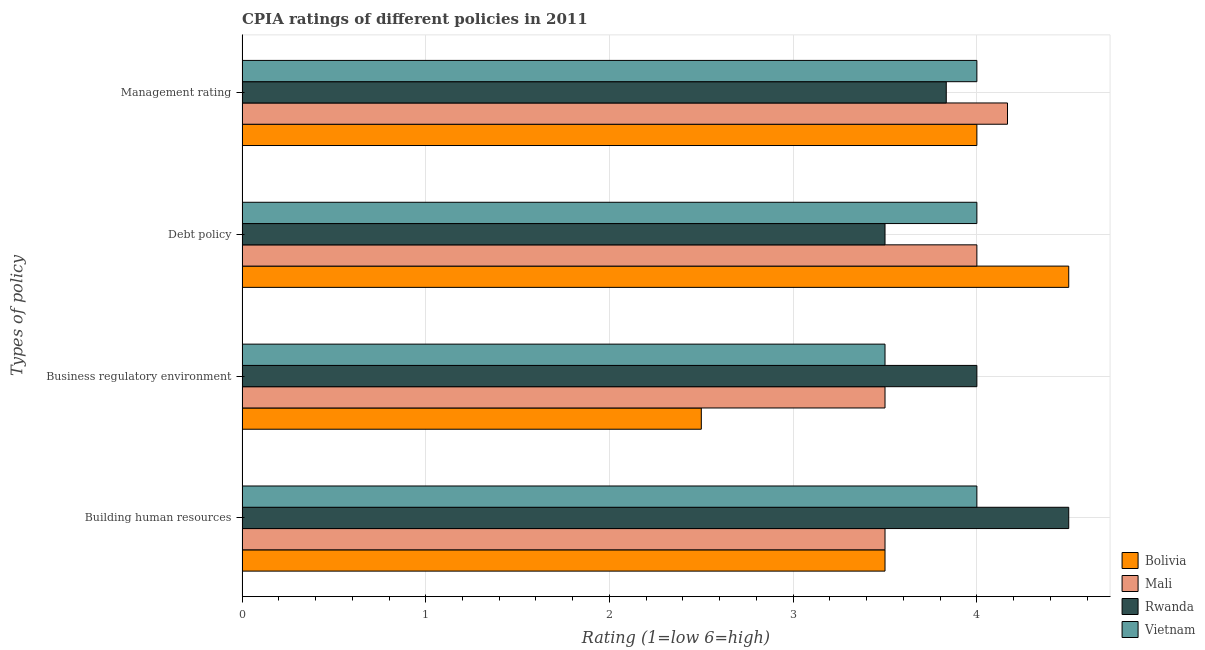How many groups of bars are there?
Your answer should be very brief. 4. Are the number of bars on each tick of the Y-axis equal?
Offer a terse response. Yes. How many bars are there on the 1st tick from the top?
Keep it short and to the point. 4. What is the label of the 1st group of bars from the top?
Offer a very short reply. Management rating. Across all countries, what is the minimum cpia rating of management?
Your answer should be very brief. 3.83. In which country was the cpia rating of building human resources minimum?
Provide a succinct answer. Bolivia. What is the difference between the cpia rating of business regulatory environment in Vietnam and the cpia rating of management in Rwanda?
Offer a terse response. -0.33. What is the average cpia rating of business regulatory environment per country?
Make the answer very short. 3.38. In how many countries, is the cpia rating of debt policy greater than 1.6 ?
Keep it short and to the point. 4. What is the ratio of the cpia rating of business regulatory environment in Vietnam to that in Bolivia?
Give a very brief answer. 1.4. Is the cpia rating of management in Mali less than that in Bolivia?
Your answer should be very brief. No. Is the difference between the cpia rating of building human resources in Rwanda and Vietnam greater than the difference between the cpia rating of business regulatory environment in Rwanda and Vietnam?
Make the answer very short. No. What is the difference between the highest and the second highest cpia rating of management?
Ensure brevity in your answer.  0.17. Is it the case that in every country, the sum of the cpia rating of business regulatory environment and cpia rating of debt policy is greater than the sum of cpia rating of management and cpia rating of building human resources?
Your answer should be compact. No. What does the 2nd bar from the top in Debt policy represents?
Ensure brevity in your answer.  Rwanda. What does the 4th bar from the bottom in Management rating represents?
Your response must be concise. Vietnam. Is it the case that in every country, the sum of the cpia rating of building human resources and cpia rating of business regulatory environment is greater than the cpia rating of debt policy?
Ensure brevity in your answer.  Yes. How many bars are there?
Your answer should be compact. 16. What is the difference between two consecutive major ticks on the X-axis?
Your response must be concise. 1. Are the values on the major ticks of X-axis written in scientific E-notation?
Your answer should be compact. No. Does the graph contain grids?
Offer a terse response. Yes. How many legend labels are there?
Make the answer very short. 4. How are the legend labels stacked?
Offer a very short reply. Vertical. What is the title of the graph?
Give a very brief answer. CPIA ratings of different policies in 2011. Does "Switzerland" appear as one of the legend labels in the graph?
Offer a very short reply. No. What is the label or title of the Y-axis?
Offer a very short reply. Types of policy. What is the Rating (1=low 6=high) in Bolivia in Building human resources?
Provide a succinct answer. 3.5. What is the Rating (1=low 6=high) of Mali in Building human resources?
Your response must be concise. 3.5. What is the Rating (1=low 6=high) in Rwanda in Building human resources?
Provide a short and direct response. 4.5. What is the Rating (1=low 6=high) of Bolivia in Business regulatory environment?
Offer a terse response. 2.5. What is the Rating (1=low 6=high) of Rwanda in Business regulatory environment?
Your answer should be compact. 4. What is the Rating (1=low 6=high) in Vietnam in Business regulatory environment?
Provide a succinct answer. 3.5. What is the Rating (1=low 6=high) of Bolivia in Debt policy?
Provide a short and direct response. 4.5. What is the Rating (1=low 6=high) in Mali in Debt policy?
Provide a short and direct response. 4. What is the Rating (1=low 6=high) in Bolivia in Management rating?
Ensure brevity in your answer.  4. What is the Rating (1=low 6=high) of Mali in Management rating?
Offer a very short reply. 4.17. What is the Rating (1=low 6=high) of Rwanda in Management rating?
Provide a short and direct response. 3.83. Across all Types of policy, what is the maximum Rating (1=low 6=high) of Bolivia?
Your answer should be very brief. 4.5. Across all Types of policy, what is the maximum Rating (1=low 6=high) of Mali?
Your answer should be compact. 4.17. Across all Types of policy, what is the maximum Rating (1=low 6=high) of Rwanda?
Offer a very short reply. 4.5. Across all Types of policy, what is the minimum Rating (1=low 6=high) of Bolivia?
Make the answer very short. 2.5. What is the total Rating (1=low 6=high) in Bolivia in the graph?
Give a very brief answer. 14.5. What is the total Rating (1=low 6=high) of Mali in the graph?
Your response must be concise. 15.17. What is the total Rating (1=low 6=high) in Rwanda in the graph?
Offer a very short reply. 15.83. What is the total Rating (1=low 6=high) in Vietnam in the graph?
Provide a succinct answer. 15.5. What is the difference between the Rating (1=low 6=high) in Bolivia in Building human resources and that in Business regulatory environment?
Make the answer very short. 1. What is the difference between the Rating (1=low 6=high) of Mali in Building human resources and that in Business regulatory environment?
Your answer should be compact. 0. What is the difference between the Rating (1=low 6=high) in Bolivia in Building human resources and that in Debt policy?
Offer a terse response. -1. What is the difference between the Rating (1=low 6=high) in Mali in Building human resources and that in Debt policy?
Ensure brevity in your answer.  -0.5. What is the difference between the Rating (1=low 6=high) of Rwanda in Building human resources and that in Debt policy?
Offer a very short reply. 1. What is the difference between the Rating (1=low 6=high) of Vietnam in Building human resources and that in Debt policy?
Offer a very short reply. 0. What is the difference between the Rating (1=low 6=high) of Bolivia in Building human resources and that in Management rating?
Provide a succinct answer. -0.5. What is the difference between the Rating (1=low 6=high) of Rwanda in Building human resources and that in Management rating?
Make the answer very short. 0.67. What is the difference between the Rating (1=low 6=high) in Rwanda in Business regulatory environment and that in Debt policy?
Keep it short and to the point. 0.5. What is the difference between the Rating (1=low 6=high) in Vietnam in Business regulatory environment and that in Debt policy?
Give a very brief answer. -0.5. What is the difference between the Rating (1=low 6=high) of Mali in Business regulatory environment and that in Management rating?
Your answer should be compact. -0.67. What is the difference between the Rating (1=low 6=high) in Vietnam in Business regulatory environment and that in Management rating?
Keep it short and to the point. -0.5. What is the difference between the Rating (1=low 6=high) in Bolivia in Debt policy and that in Management rating?
Ensure brevity in your answer.  0.5. What is the difference between the Rating (1=low 6=high) of Rwanda in Debt policy and that in Management rating?
Make the answer very short. -0.33. What is the difference between the Rating (1=low 6=high) of Vietnam in Debt policy and that in Management rating?
Your response must be concise. 0. What is the difference between the Rating (1=low 6=high) of Bolivia in Building human resources and the Rating (1=low 6=high) of Mali in Business regulatory environment?
Give a very brief answer. 0. What is the difference between the Rating (1=low 6=high) in Bolivia in Building human resources and the Rating (1=low 6=high) in Rwanda in Business regulatory environment?
Offer a very short reply. -0.5. What is the difference between the Rating (1=low 6=high) of Mali in Building human resources and the Rating (1=low 6=high) of Rwanda in Business regulatory environment?
Give a very brief answer. -0.5. What is the difference between the Rating (1=low 6=high) in Rwanda in Building human resources and the Rating (1=low 6=high) in Vietnam in Business regulatory environment?
Offer a very short reply. 1. What is the difference between the Rating (1=low 6=high) of Bolivia in Building human resources and the Rating (1=low 6=high) of Mali in Debt policy?
Keep it short and to the point. -0.5. What is the difference between the Rating (1=low 6=high) in Bolivia in Building human resources and the Rating (1=low 6=high) in Rwanda in Debt policy?
Provide a short and direct response. 0. What is the difference between the Rating (1=low 6=high) of Bolivia in Building human resources and the Rating (1=low 6=high) of Vietnam in Debt policy?
Make the answer very short. -0.5. What is the difference between the Rating (1=low 6=high) of Bolivia in Building human resources and the Rating (1=low 6=high) of Vietnam in Management rating?
Make the answer very short. -0.5. What is the difference between the Rating (1=low 6=high) in Mali in Building human resources and the Rating (1=low 6=high) in Rwanda in Management rating?
Offer a very short reply. -0.33. What is the difference between the Rating (1=low 6=high) in Rwanda in Building human resources and the Rating (1=low 6=high) in Vietnam in Management rating?
Give a very brief answer. 0.5. What is the difference between the Rating (1=low 6=high) in Bolivia in Business regulatory environment and the Rating (1=low 6=high) in Rwanda in Debt policy?
Keep it short and to the point. -1. What is the difference between the Rating (1=low 6=high) of Mali in Business regulatory environment and the Rating (1=low 6=high) of Vietnam in Debt policy?
Provide a short and direct response. -0.5. What is the difference between the Rating (1=low 6=high) in Bolivia in Business regulatory environment and the Rating (1=low 6=high) in Mali in Management rating?
Provide a short and direct response. -1.67. What is the difference between the Rating (1=low 6=high) of Bolivia in Business regulatory environment and the Rating (1=low 6=high) of Rwanda in Management rating?
Give a very brief answer. -1.33. What is the difference between the Rating (1=low 6=high) in Bolivia in Business regulatory environment and the Rating (1=low 6=high) in Vietnam in Management rating?
Ensure brevity in your answer.  -1.5. What is the difference between the Rating (1=low 6=high) of Mali in Business regulatory environment and the Rating (1=low 6=high) of Rwanda in Management rating?
Offer a very short reply. -0.33. What is the difference between the Rating (1=low 6=high) of Mali in Business regulatory environment and the Rating (1=low 6=high) of Vietnam in Management rating?
Offer a terse response. -0.5. What is the difference between the Rating (1=low 6=high) in Rwanda in Business regulatory environment and the Rating (1=low 6=high) in Vietnam in Management rating?
Ensure brevity in your answer.  0. What is the difference between the Rating (1=low 6=high) in Bolivia in Debt policy and the Rating (1=low 6=high) in Mali in Management rating?
Your answer should be compact. 0.33. What is the difference between the Rating (1=low 6=high) of Bolivia in Debt policy and the Rating (1=low 6=high) of Rwanda in Management rating?
Offer a very short reply. 0.67. What is the average Rating (1=low 6=high) in Bolivia per Types of policy?
Make the answer very short. 3.62. What is the average Rating (1=low 6=high) in Mali per Types of policy?
Offer a very short reply. 3.79. What is the average Rating (1=low 6=high) of Rwanda per Types of policy?
Your answer should be very brief. 3.96. What is the average Rating (1=low 6=high) in Vietnam per Types of policy?
Your answer should be compact. 3.88. What is the difference between the Rating (1=low 6=high) of Bolivia and Rating (1=low 6=high) of Mali in Building human resources?
Your answer should be very brief. 0. What is the difference between the Rating (1=low 6=high) of Bolivia and Rating (1=low 6=high) of Rwanda in Building human resources?
Make the answer very short. -1. What is the difference between the Rating (1=low 6=high) in Bolivia and Rating (1=low 6=high) in Vietnam in Building human resources?
Your answer should be very brief. -0.5. What is the difference between the Rating (1=low 6=high) in Bolivia and Rating (1=low 6=high) in Rwanda in Business regulatory environment?
Your answer should be compact. -1.5. What is the difference between the Rating (1=low 6=high) in Mali and Rating (1=low 6=high) in Rwanda in Business regulatory environment?
Offer a terse response. -0.5. What is the difference between the Rating (1=low 6=high) in Mali and Rating (1=low 6=high) in Vietnam in Business regulatory environment?
Offer a very short reply. 0. What is the difference between the Rating (1=low 6=high) of Rwanda and Rating (1=low 6=high) of Vietnam in Business regulatory environment?
Offer a terse response. 0.5. What is the difference between the Rating (1=low 6=high) of Bolivia and Rating (1=low 6=high) of Rwanda in Debt policy?
Keep it short and to the point. 1. What is the difference between the Rating (1=low 6=high) of Mali and Rating (1=low 6=high) of Vietnam in Debt policy?
Keep it short and to the point. 0. What is the difference between the Rating (1=low 6=high) of Bolivia and Rating (1=low 6=high) of Mali in Management rating?
Keep it short and to the point. -0.17. What is the difference between the Rating (1=low 6=high) in Bolivia and Rating (1=low 6=high) in Vietnam in Management rating?
Offer a terse response. 0. What is the difference between the Rating (1=low 6=high) in Mali and Rating (1=low 6=high) in Rwanda in Management rating?
Your response must be concise. 0.33. What is the difference between the Rating (1=low 6=high) in Mali and Rating (1=low 6=high) in Vietnam in Management rating?
Your answer should be compact. 0.17. What is the difference between the Rating (1=low 6=high) of Rwanda and Rating (1=low 6=high) of Vietnam in Management rating?
Keep it short and to the point. -0.17. What is the ratio of the Rating (1=low 6=high) in Bolivia in Building human resources to that in Business regulatory environment?
Provide a short and direct response. 1.4. What is the ratio of the Rating (1=low 6=high) in Mali in Building human resources to that in Business regulatory environment?
Ensure brevity in your answer.  1. What is the ratio of the Rating (1=low 6=high) of Vietnam in Building human resources to that in Business regulatory environment?
Your response must be concise. 1.14. What is the ratio of the Rating (1=low 6=high) of Bolivia in Building human resources to that in Debt policy?
Keep it short and to the point. 0.78. What is the ratio of the Rating (1=low 6=high) of Vietnam in Building human resources to that in Debt policy?
Make the answer very short. 1. What is the ratio of the Rating (1=low 6=high) in Bolivia in Building human resources to that in Management rating?
Make the answer very short. 0.88. What is the ratio of the Rating (1=low 6=high) in Mali in Building human resources to that in Management rating?
Keep it short and to the point. 0.84. What is the ratio of the Rating (1=low 6=high) of Rwanda in Building human resources to that in Management rating?
Provide a short and direct response. 1.17. What is the ratio of the Rating (1=low 6=high) of Vietnam in Building human resources to that in Management rating?
Keep it short and to the point. 1. What is the ratio of the Rating (1=low 6=high) of Bolivia in Business regulatory environment to that in Debt policy?
Ensure brevity in your answer.  0.56. What is the ratio of the Rating (1=low 6=high) of Mali in Business regulatory environment to that in Debt policy?
Your answer should be very brief. 0.88. What is the ratio of the Rating (1=low 6=high) of Rwanda in Business regulatory environment to that in Debt policy?
Provide a succinct answer. 1.14. What is the ratio of the Rating (1=low 6=high) of Vietnam in Business regulatory environment to that in Debt policy?
Make the answer very short. 0.88. What is the ratio of the Rating (1=low 6=high) of Bolivia in Business regulatory environment to that in Management rating?
Your response must be concise. 0.62. What is the ratio of the Rating (1=low 6=high) in Mali in Business regulatory environment to that in Management rating?
Offer a very short reply. 0.84. What is the ratio of the Rating (1=low 6=high) in Rwanda in Business regulatory environment to that in Management rating?
Ensure brevity in your answer.  1.04. What is the ratio of the Rating (1=low 6=high) in Bolivia in Debt policy to that in Management rating?
Keep it short and to the point. 1.12. What is the ratio of the Rating (1=low 6=high) of Rwanda in Debt policy to that in Management rating?
Provide a succinct answer. 0.91. What is the ratio of the Rating (1=low 6=high) in Vietnam in Debt policy to that in Management rating?
Your answer should be compact. 1. What is the difference between the highest and the second highest Rating (1=low 6=high) of Bolivia?
Your answer should be compact. 0.5. What is the difference between the highest and the second highest Rating (1=low 6=high) of Vietnam?
Make the answer very short. 0. What is the difference between the highest and the lowest Rating (1=low 6=high) of Rwanda?
Provide a succinct answer. 1. 